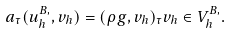<formula> <loc_0><loc_0><loc_500><loc_500>a _ { \tau } ( u ^ { B , } _ { h } , v _ { h } ) = ( \rho g , v _ { h } ) _ { \tau } v _ { h } \in V _ { h } ^ { B , } .</formula> 